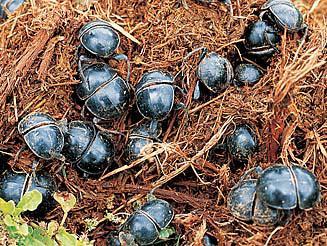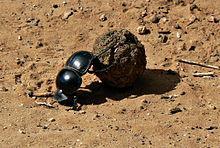The first image is the image on the left, the second image is the image on the right. Analyze the images presented: Is the assertion "There is exactly one insect in the image on the left." valid? Answer yes or no. No. 